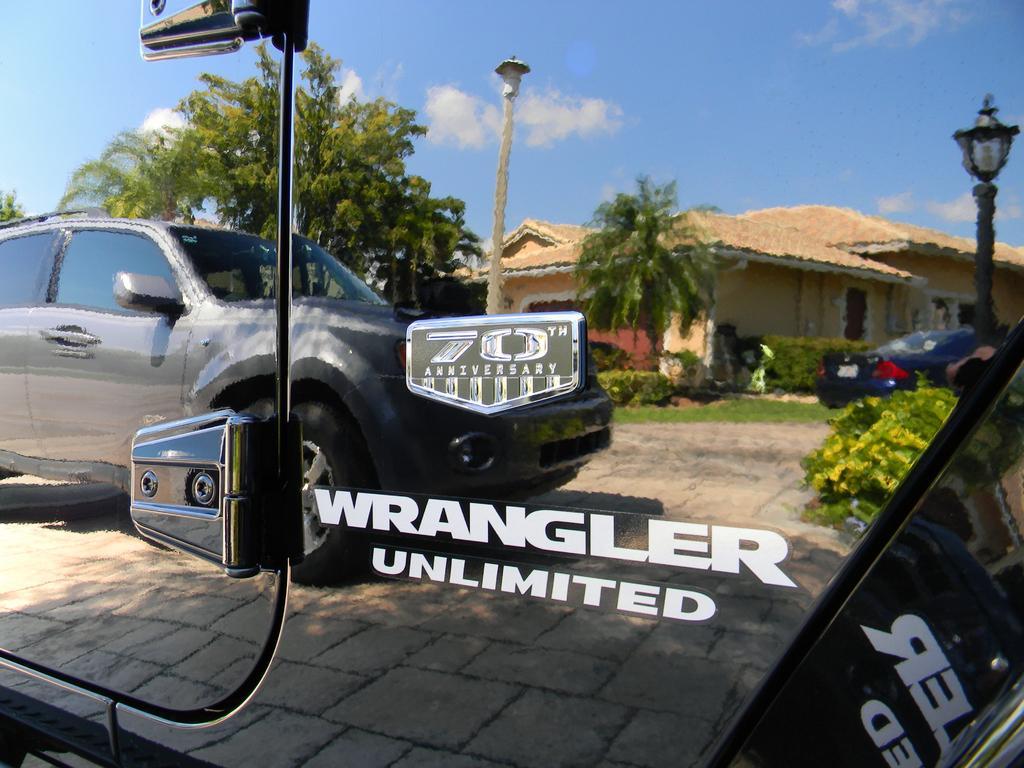In one or two sentences, can you explain what this image depicts? This is a car. On car we can see the text and reflection. In this picture we can see a building, roof, trees, cars, poles, lights, plants, grass, ground, road and clouds are present in the sky. 